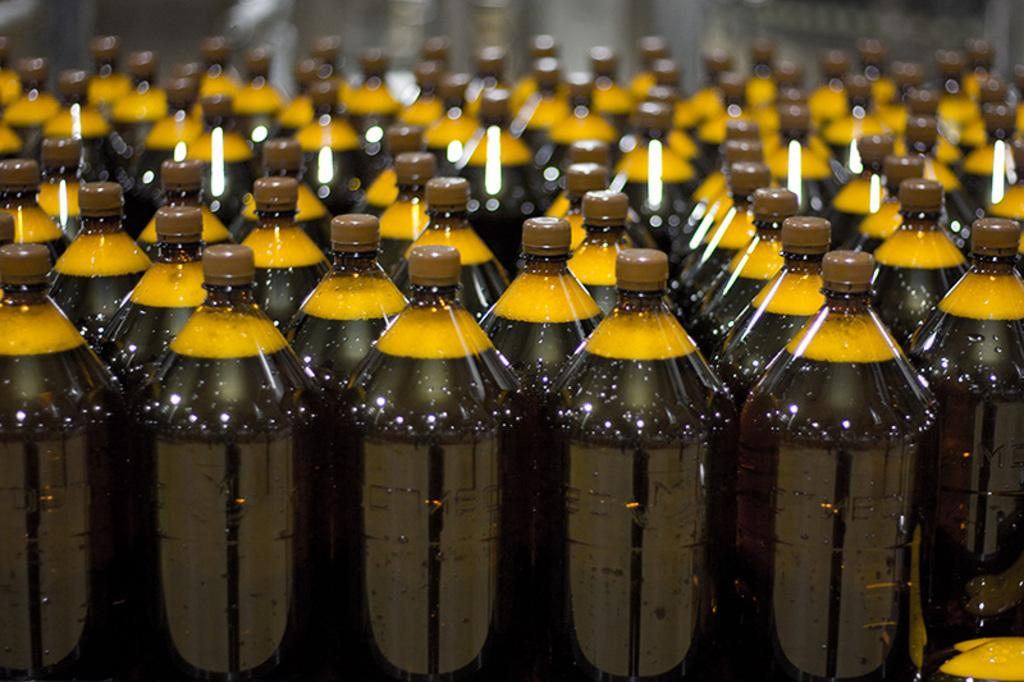What objects can be seen in the image? There are bottles in the image. What is the color of the liquid inside the bottles? The liquid in the bottles is black in color. What is the color of the foam in the bottles? The foam in the bottles is yellow in color. What is the color of the caps on the bottles? The caps of the bottles are brown in color. What type of cave can be seen in the image? There is no cave present in the image; it features bottles with black liquid, yellow foam, and brown caps. How does the sleet affect the oven in the image? There is no oven or sleet present in the image. 